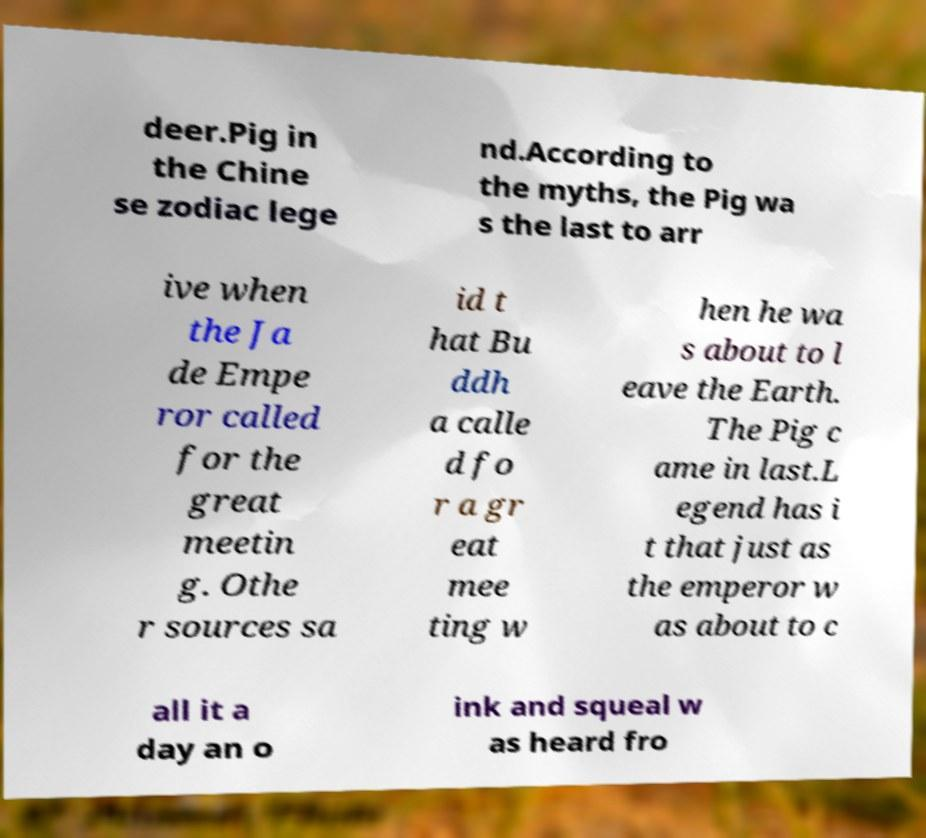Can you read and provide the text displayed in the image?This photo seems to have some interesting text. Can you extract and type it out for me? deer.Pig in the Chine se zodiac lege nd.According to the myths, the Pig wa s the last to arr ive when the Ja de Empe ror called for the great meetin g. Othe r sources sa id t hat Bu ddh a calle d fo r a gr eat mee ting w hen he wa s about to l eave the Earth. The Pig c ame in last.L egend has i t that just as the emperor w as about to c all it a day an o ink and squeal w as heard fro 